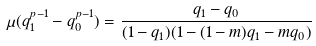<formula> <loc_0><loc_0><loc_500><loc_500>\mu ( q _ { 1 } ^ { p - 1 } - q _ { 0 } ^ { p - 1 } ) = \frac { q _ { 1 } - q _ { 0 } } { ( 1 - q _ { 1 } ) ( 1 - ( 1 - m ) q _ { 1 } - m q _ { 0 } ) }</formula> 